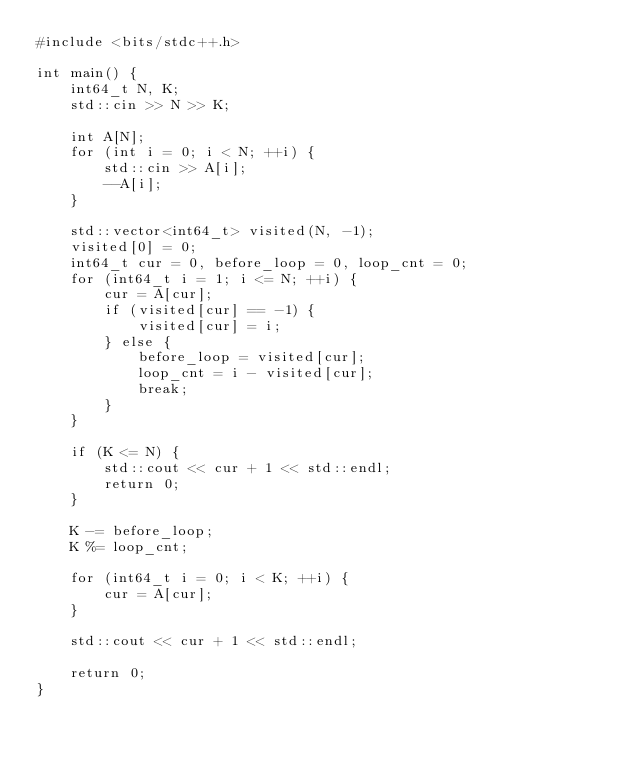Convert code to text. <code><loc_0><loc_0><loc_500><loc_500><_C++_>#include <bits/stdc++.h>

int main() {
    int64_t N, K;
    std::cin >> N >> K;

    int A[N];
    for (int i = 0; i < N; ++i) {
        std::cin >> A[i];
        --A[i];
    }

    std::vector<int64_t> visited(N, -1);
    visited[0] = 0;
    int64_t cur = 0, before_loop = 0, loop_cnt = 0;
    for (int64_t i = 1; i <= N; ++i) {
        cur = A[cur];
        if (visited[cur] == -1) {
            visited[cur] = i;
        } else {
            before_loop = visited[cur];
            loop_cnt = i - visited[cur];
            break;
        } 
    }

    if (K <= N) {
        std::cout << cur + 1 << std::endl;
        return 0;
    }

    K -= before_loop;
    K %= loop_cnt;

    for (int64_t i = 0; i < K; ++i) {
        cur = A[cur];
    }

    std::cout << cur + 1 << std::endl;

    return 0;
}
</code> 